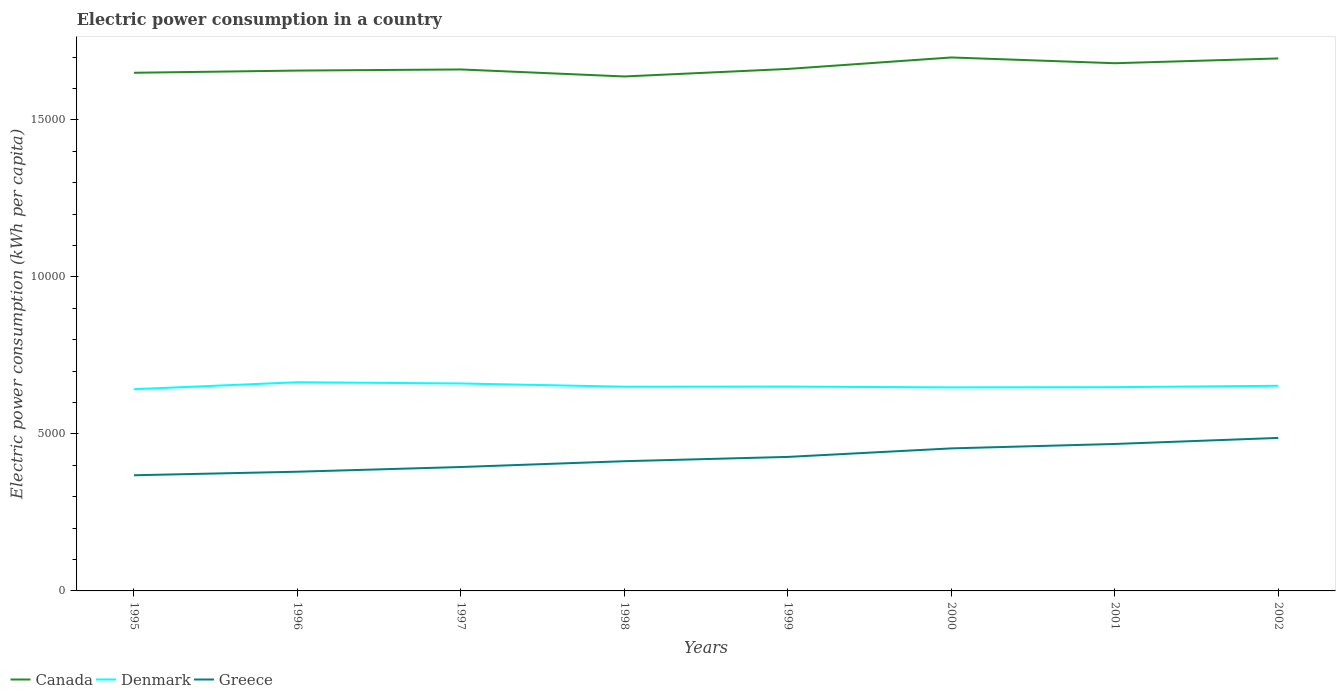How many different coloured lines are there?
Ensure brevity in your answer.  3. Does the line corresponding to Canada intersect with the line corresponding to Denmark?
Give a very brief answer. No. Across all years, what is the maximum electric power consumption in in Canada?
Ensure brevity in your answer.  1.64e+04. What is the total electric power consumption in in Canada in the graph?
Keep it short and to the point. -574.2. What is the difference between the highest and the second highest electric power consumption in in Greece?
Provide a succinct answer. 1189.32. What is the difference between the highest and the lowest electric power consumption in in Greece?
Ensure brevity in your answer.  4. How many lines are there?
Offer a very short reply. 3. How many years are there in the graph?
Your answer should be very brief. 8. Are the values on the major ticks of Y-axis written in scientific E-notation?
Offer a terse response. No. Where does the legend appear in the graph?
Offer a terse response. Bottom left. How many legend labels are there?
Your answer should be very brief. 3. How are the legend labels stacked?
Your response must be concise. Horizontal. What is the title of the graph?
Provide a succinct answer. Electric power consumption in a country. What is the label or title of the Y-axis?
Your answer should be very brief. Electric power consumption (kWh per capita). What is the Electric power consumption (kWh per capita) in Canada in 1995?
Ensure brevity in your answer.  1.65e+04. What is the Electric power consumption (kWh per capita) in Denmark in 1995?
Your response must be concise. 6424.54. What is the Electric power consumption (kWh per capita) in Greece in 1995?
Offer a terse response. 3683.8. What is the Electric power consumption (kWh per capita) in Canada in 1996?
Your answer should be compact. 1.66e+04. What is the Electric power consumption (kWh per capita) in Denmark in 1996?
Give a very brief answer. 6646.69. What is the Electric power consumption (kWh per capita) in Greece in 1996?
Offer a very short reply. 3796.75. What is the Electric power consumption (kWh per capita) of Canada in 1997?
Your response must be concise. 1.66e+04. What is the Electric power consumption (kWh per capita) of Denmark in 1997?
Your answer should be very brief. 6607.2. What is the Electric power consumption (kWh per capita) of Greece in 1997?
Offer a very short reply. 3946.46. What is the Electric power consumption (kWh per capita) in Canada in 1998?
Give a very brief answer. 1.64e+04. What is the Electric power consumption (kWh per capita) of Denmark in 1998?
Ensure brevity in your answer.  6504.26. What is the Electric power consumption (kWh per capita) in Greece in 1998?
Make the answer very short. 4131.66. What is the Electric power consumption (kWh per capita) in Canada in 1999?
Your answer should be very brief. 1.66e+04. What is the Electric power consumption (kWh per capita) in Denmark in 1999?
Your answer should be very brief. 6508.51. What is the Electric power consumption (kWh per capita) in Greece in 1999?
Your response must be concise. 4268.38. What is the Electric power consumption (kWh per capita) of Canada in 2000?
Provide a succinct answer. 1.70e+04. What is the Electric power consumption (kWh per capita) in Denmark in 2000?
Provide a short and direct response. 6482.49. What is the Electric power consumption (kWh per capita) in Greece in 2000?
Give a very brief answer. 4539.42. What is the Electric power consumption (kWh per capita) of Canada in 2001?
Provide a short and direct response. 1.68e+04. What is the Electric power consumption (kWh per capita) of Denmark in 2001?
Ensure brevity in your answer.  6490.09. What is the Electric power consumption (kWh per capita) in Greece in 2001?
Your answer should be very brief. 4680.52. What is the Electric power consumption (kWh per capita) in Canada in 2002?
Offer a terse response. 1.70e+04. What is the Electric power consumption (kWh per capita) in Denmark in 2002?
Your answer should be very brief. 6533.75. What is the Electric power consumption (kWh per capita) in Greece in 2002?
Your answer should be compact. 4873.12. Across all years, what is the maximum Electric power consumption (kWh per capita) in Canada?
Make the answer very short. 1.70e+04. Across all years, what is the maximum Electric power consumption (kWh per capita) of Denmark?
Make the answer very short. 6646.69. Across all years, what is the maximum Electric power consumption (kWh per capita) of Greece?
Ensure brevity in your answer.  4873.12. Across all years, what is the minimum Electric power consumption (kWh per capita) of Canada?
Give a very brief answer. 1.64e+04. Across all years, what is the minimum Electric power consumption (kWh per capita) of Denmark?
Your answer should be compact. 6424.54. Across all years, what is the minimum Electric power consumption (kWh per capita) of Greece?
Offer a terse response. 3683.8. What is the total Electric power consumption (kWh per capita) in Canada in the graph?
Keep it short and to the point. 1.33e+05. What is the total Electric power consumption (kWh per capita) of Denmark in the graph?
Give a very brief answer. 5.22e+04. What is the total Electric power consumption (kWh per capita) in Greece in the graph?
Your answer should be compact. 3.39e+04. What is the difference between the Electric power consumption (kWh per capita) in Canada in 1995 and that in 1996?
Offer a terse response. -69.41. What is the difference between the Electric power consumption (kWh per capita) in Denmark in 1995 and that in 1996?
Give a very brief answer. -222.15. What is the difference between the Electric power consumption (kWh per capita) of Greece in 1995 and that in 1996?
Provide a short and direct response. -112.94. What is the difference between the Electric power consumption (kWh per capita) in Canada in 1995 and that in 1997?
Offer a terse response. -105.28. What is the difference between the Electric power consumption (kWh per capita) in Denmark in 1995 and that in 1997?
Make the answer very short. -182.66. What is the difference between the Electric power consumption (kWh per capita) of Greece in 1995 and that in 1997?
Provide a succinct answer. -262.65. What is the difference between the Electric power consumption (kWh per capita) in Canada in 1995 and that in 1998?
Give a very brief answer. 117.87. What is the difference between the Electric power consumption (kWh per capita) of Denmark in 1995 and that in 1998?
Give a very brief answer. -79.72. What is the difference between the Electric power consumption (kWh per capita) of Greece in 1995 and that in 1998?
Your response must be concise. -447.85. What is the difference between the Electric power consumption (kWh per capita) in Canada in 1995 and that in 1999?
Offer a very short reply. -122.12. What is the difference between the Electric power consumption (kWh per capita) in Denmark in 1995 and that in 1999?
Your response must be concise. -83.98. What is the difference between the Electric power consumption (kWh per capita) in Greece in 1995 and that in 1999?
Your answer should be very brief. -584.58. What is the difference between the Electric power consumption (kWh per capita) of Canada in 1995 and that in 2000?
Provide a short and direct response. -487.31. What is the difference between the Electric power consumption (kWh per capita) in Denmark in 1995 and that in 2000?
Your answer should be very brief. -57.95. What is the difference between the Electric power consumption (kWh per capita) in Greece in 1995 and that in 2000?
Give a very brief answer. -855.61. What is the difference between the Electric power consumption (kWh per capita) of Canada in 1995 and that in 2001?
Make the answer very short. -303.87. What is the difference between the Electric power consumption (kWh per capita) of Denmark in 1995 and that in 2001?
Offer a very short reply. -65.56. What is the difference between the Electric power consumption (kWh per capita) of Greece in 1995 and that in 2001?
Offer a very short reply. -996.72. What is the difference between the Electric power consumption (kWh per capita) in Canada in 1995 and that in 2002?
Ensure brevity in your answer.  -456.33. What is the difference between the Electric power consumption (kWh per capita) in Denmark in 1995 and that in 2002?
Ensure brevity in your answer.  -109.21. What is the difference between the Electric power consumption (kWh per capita) in Greece in 1995 and that in 2002?
Provide a short and direct response. -1189.32. What is the difference between the Electric power consumption (kWh per capita) in Canada in 1996 and that in 1997?
Offer a very short reply. -35.87. What is the difference between the Electric power consumption (kWh per capita) in Denmark in 1996 and that in 1997?
Offer a terse response. 39.48. What is the difference between the Electric power consumption (kWh per capita) of Greece in 1996 and that in 1997?
Give a very brief answer. -149.71. What is the difference between the Electric power consumption (kWh per capita) in Canada in 1996 and that in 1998?
Your answer should be very brief. 187.28. What is the difference between the Electric power consumption (kWh per capita) of Denmark in 1996 and that in 1998?
Offer a very short reply. 142.43. What is the difference between the Electric power consumption (kWh per capita) of Greece in 1996 and that in 1998?
Provide a succinct answer. -334.91. What is the difference between the Electric power consumption (kWh per capita) in Canada in 1996 and that in 1999?
Your answer should be compact. -52.7. What is the difference between the Electric power consumption (kWh per capita) in Denmark in 1996 and that in 1999?
Offer a terse response. 138.17. What is the difference between the Electric power consumption (kWh per capita) of Greece in 1996 and that in 1999?
Offer a very short reply. -471.64. What is the difference between the Electric power consumption (kWh per capita) of Canada in 1996 and that in 2000?
Your response must be concise. -417.9. What is the difference between the Electric power consumption (kWh per capita) of Denmark in 1996 and that in 2000?
Give a very brief answer. 164.2. What is the difference between the Electric power consumption (kWh per capita) of Greece in 1996 and that in 2000?
Provide a succinct answer. -742.67. What is the difference between the Electric power consumption (kWh per capita) in Canada in 1996 and that in 2001?
Provide a succinct answer. -234.46. What is the difference between the Electric power consumption (kWh per capita) in Denmark in 1996 and that in 2001?
Make the answer very short. 156.59. What is the difference between the Electric power consumption (kWh per capita) in Greece in 1996 and that in 2001?
Offer a terse response. -883.78. What is the difference between the Electric power consumption (kWh per capita) of Canada in 1996 and that in 2002?
Give a very brief answer. -386.92. What is the difference between the Electric power consumption (kWh per capita) of Denmark in 1996 and that in 2002?
Offer a very short reply. 112.93. What is the difference between the Electric power consumption (kWh per capita) of Greece in 1996 and that in 2002?
Ensure brevity in your answer.  -1076.37. What is the difference between the Electric power consumption (kWh per capita) in Canada in 1997 and that in 1998?
Provide a succinct answer. 223.15. What is the difference between the Electric power consumption (kWh per capita) of Denmark in 1997 and that in 1998?
Provide a short and direct response. 102.95. What is the difference between the Electric power consumption (kWh per capita) in Greece in 1997 and that in 1998?
Ensure brevity in your answer.  -185.2. What is the difference between the Electric power consumption (kWh per capita) in Canada in 1997 and that in 1999?
Give a very brief answer. -16.83. What is the difference between the Electric power consumption (kWh per capita) of Denmark in 1997 and that in 1999?
Keep it short and to the point. 98.69. What is the difference between the Electric power consumption (kWh per capita) of Greece in 1997 and that in 1999?
Give a very brief answer. -321.93. What is the difference between the Electric power consumption (kWh per capita) in Canada in 1997 and that in 2000?
Keep it short and to the point. -382.03. What is the difference between the Electric power consumption (kWh per capita) in Denmark in 1997 and that in 2000?
Give a very brief answer. 124.71. What is the difference between the Electric power consumption (kWh per capita) of Greece in 1997 and that in 2000?
Keep it short and to the point. -592.96. What is the difference between the Electric power consumption (kWh per capita) of Canada in 1997 and that in 2001?
Your answer should be compact. -198.59. What is the difference between the Electric power consumption (kWh per capita) of Denmark in 1997 and that in 2001?
Ensure brevity in your answer.  117.11. What is the difference between the Electric power consumption (kWh per capita) of Greece in 1997 and that in 2001?
Offer a very short reply. -734.07. What is the difference between the Electric power consumption (kWh per capita) of Canada in 1997 and that in 2002?
Offer a very short reply. -351.05. What is the difference between the Electric power consumption (kWh per capita) in Denmark in 1997 and that in 2002?
Offer a terse response. 73.45. What is the difference between the Electric power consumption (kWh per capita) in Greece in 1997 and that in 2002?
Offer a terse response. -926.66. What is the difference between the Electric power consumption (kWh per capita) of Canada in 1998 and that in 1999?
Provide a short and direct response. -239.98. What is the difference between the Electric power consumption (kWh per capita) in Denmark in 1998 and that in 1999?
Your response must be concise. -4.26. What is the difference between the Electric power consumption (kWh per capita) of Greece in 1998 and that in 1999?
Your response must be concise. -136.72. What is the difference between the Electric power consumption (kWh per capita) of Canada in 1998 and that in 2000?
Ensure brevity in your answer.  -605.18. What is the difference between the Electric power consumption (kWh per capita) of Denmark in 1998 and that in 2000?
Provide a short and direct response. 21.77. What is the difference between the Electric power consumption (kWh per capita) of Greece in 1998 and that in 2000?
Provide a succinct answer. -407.76. What is the difference between the Electric power consumption (kWh per capita) of Canada in 1998 and that in 2001?
Ensure brevity in your answer.  -421.74. What is the difference between the Electric power consumption (kWh per capita) of Denmark in 1998 and that in 2001?
Give a very brief answer. 14.16. What is the difference between the Electric power consumption (kWh per capita) of Greece in 1998 and that in 2001?
Provide a short and direct response. -548.87. What is the difference between the Electric power consumption (kWh per capita) in Canada in 1998 and that in 2002?
Provide a succinct answer. -574.2. What is the difference between the Electric power consumption (kWh per capita) of Denmark in 1998 and that in 2002?
Your answer should be very brief. -29.5. What is the difference between the Electric power consumption (kWh per capita) in Greece in 1998 and that in 2002?
Offer a terse response. -741.46. What is the difference between the Electric power consumption (kWh per capita) in Canada in 1999 and that in 2000?
Keep it short and to the point. -365.19. What is the difference between the Electric power consumption (kWh per capita) in Denmark in 1999 and that in 2000?
Your answer should be very brief. 26.02. What is the difference between the Electric power consumption (kWh per capita) of Greece in 1999 and that in 2000?
Your response must be concise. -271.04. What is the difference between the Electric power consumption (kWh per capita) in Canada in 1999 and that in 2001?
Your answer should be compact. -181.76. What is the difference between the Electric power consumption (kWh per capita) of Denmark in 1999 and that in 2001?
Your answer should be very brief. 18.42. What is the difference between the Electric power consumption (kWh per capita) of Greece in 1999 and that in 2001?
Keep it short and to the point. -412.14. What is the difference between the Electric power consumption (kWh per capita) in Canada in 1999 and that in 2002?
Your answer should be compact. -334.21. What is the difference between the Electric power consumption (kWh per capita) of Denmark in 1999 and that in 2002?
Offer a very short reply. -25.24. What is the difference between the Electric power consumption (kWh per capita) of Greece in 1999 and that in 2002?
Keep it short and to the point. -604.74. What is the difference between the Electric power consumption (kWh per capita) of Canada in 2000 and that in 2001?
Offer a terse response. 183.43. What is the difference between the Electric power consumption (kWh per capita) of Denmark in 2000 and that in 2001?
Give a very brief answer. -7.6. What is the difference between the Electric power consumption (kWh per capita) in Greece in 2000 and that in 2001?
Provide a short and direct response. -141.11. What is the difference between the Electric power consumption (kWh per capita) of Canada in 2000 and that in 2002?
Your answer should be compact. 30.98. What is the difference between the Electric power consumption (kWh per capita) of Denmark in 2000 and that in 2002?
Ensure brevity in your answer.  -51.26. What is the difference between the Electric power consumption (kWh per capita) of Greece in 2000 and that in 2002?
Your response must be concise. -333.7. What is the difference between the Electric power consumption (kWh per capita) of Canada in 2001 and that in 2002?
Give a very brief answer. -152.46. What is the difference between the Electric power consumption (kWh per capita) of Denmark in 2001 and that in 2002?
Provide a succinct answer. -43.66. What is the difference between the Electric power consumption (kWh per capita) of Greece in 2001 and that in 2002?
Provide a succinct answer. -192.6. What is the difference between the Electric power consumption (kWh per capita) of Canada in 1995 and the Electric power consumption (kWh per capita) of Denmark in 1996?
Offer a very short reply. 9856.58. What is the difference between the Electric power consumption (kWh per capita) in Canada in 1995 and the Electric power consumption (kWh per capita) in Greece in 1996?
Give a very brief answer. 1.27e+04. What is the difference between the Electric power consumption (kWh per capita) in Denmark in 1995 and the Electric power consumption (kWh per capita) in Greece in 1996?
Provide a succinct answer. 2627.79. What is the difference between the Electric power consumption (kWh per capita) of Canada in 1995 and the Electric power consumption (kWh per capita) of Denmark in 1997?
Ensure brevity in your answer.  9896.07. What is the difference between the Electric power consumption (kWh per capita) of Canada in 1995 and the Electric power consumption (kWh per capita) of Greece in 1997?
Provide a succinct answer. 1.26e+04. What is the difference between the Electric power consumption (kWh per capita) in Denmark in 1995 and the Electric power consumption (kWh per capita) in Greece in 1997?
Your response must be concise. 2478.08. What is the difference between the Electric power consumption (kWh per capita) in Canada in 1995 and the Electric power consumption (kWh per capita) in Denmark in 1998?
Make the answer very short. 9999.01. What is the difference between the Electric power consumption (kWh per capita) of Canada in 1995 and the Electric power consumption (kWh per capita) of Greece in 1998?
Offer a terse response. 1.24e+04. What is the difference between the Electric power consumption (kWh per capita) in Denmark in 1995 and the Electric power consumption (kWh per capita) in Greece in 1998?
Provide a succinct answer. 2292.88. What is the difference between the Electric power consumption (kWh per capita) in Canada in 1995 and the Electric power consumption (kWh per capita) in Denmark in 1999?
Your answer should be compact. 9994.76. What is the difference between the Electric power consumption (kWh per capita) of Canada in 1995 and the Electric power consumption (kWh per capita) of Greece in 1999?
Provide a succinct answer. 1.22e+04. What is the difference between the Electric power consumption (kWh per capita) of Denmark in 1995 and the Electric power consumption (kWh per capita) of Greece in 1999?
Keep it short and to the point. 2156.16. What is the difference between the Electric power consumption (kWh per capita) in Canada in 1995 and the Electric power consumption (kWh per capita) in Denmark in 2000?
Keep it short and to the point. 1.00e+04. What is the difference between the Electric power consumption (kWh per capita) in Canada in 1995 and the Electric power consumption (kWh per capita) in Greece in 2000?
Provide a succinct answer. 1.20e+04. What is the difference between the Electric power consumption (kWh per capita) in Denmark in 1995 and the Electric power consumption (kWh per capita) in Greece in 2000?
Keep it short and to the point. 1885.12. What is the difference between the Electric power consumption (kWh per capita) of Canada in 1995 and the Electric power consumption (kWh per capita) of Denmark in 2001?
Keep it short and to the point. 1.00e+04. What is the difference between the Electric power consumption (kWh per capita) of Canada in 1995 and the Electric power consumption (kWh per capita) of Greece in 2001?
Give a very brief answer. 1.18e+04. What is the difference between the Electric power consumption (kWh per capita) of Denmark in 1995 and the Electric power consumption (kWh per capita) of Greece in 2001?
Keep it short and to the point. 1744.01. What is the difference between the Electric power consumption (kWh per capita) in Canada in 1995 and the Electric power consumption (kWh per capita) in Denmark in 2002?
Provide a succinct answer. 9969.52. What is the difference between the Electric power consumption (kWh per capita) of Canada in 1995 and the Electric power consumption (kWh per capita) of Greece in 2002?
Offer a very short reply. 1.16e+04. What is the difference between the Electric power consumption (kWh per capita) in Denmark in 1995 and the Electric power consumption (kWh per capita) in Greece in 2002?
Provide a succinct answer. 1551.42. What is the difference between the Electric power consumption (kWh per capita) of Canada in 1996 and the Electric power consumption (kWh per capita) of Denmark in 1997?
Keep it short and to the point. 9965.48. What is the difference between the Electric power consumption (kWh per capita) in Canada in 1996 and the Electric power consumption (kWh per capita) in Greece in 1997?
Provide a succinct answer. 1.26e+04. What is the difference between the Electric power consumption (kWh per capita) in Denmark in 1996 and the Electric power consumption (kWh per capita) in Greece in 1997?
Provide a short and direct response. 2700.23. What is the difference between the Electric power consumption (kWh per capita) of Canada in 1996 and the Electric power consumption (kWh per capita) of Denmark in 1998?
Make the answer very short. 1.01e+04. What is the difference between the Electric power consumption (kWh per capita) in Canada in 1996 and the Electric power consumption (kWh per capita) in Greece in 1998?
Your response must be concise. 1.24e+04. What is the difference between the Electric power consumption (kWh per capita) in Denmark in 1996 and the Electric power consumption (kWh per capita) in Greece in 1998?
Ensure brevity in your answer.  2515.03. What is the difference between the Electric power consumption (kWh per capita) in Canada in 1996 and the Electric power consumption (kWh per capita) in Denmark in 1999?
Your response must be concise. 1.01e+04. What is the difference between the Electric power consumption (kWh per capita) in Canada in 1996 and the Electric power consumption (kWh per capita) in Greece in 1999?
Offer a terse response. 1.23e+04. What is the difference between the Electric power consumption (kWh per capita) in Denmark in 1996 and the Electric power consumption (kWh per capita) in Greece in 1999?
Offer a very short reply. 2378.3. What is the difference between the Electric power consumption (kWh per capita) in Canada in 1996 and the Electric power consumption (kWh per capita) in Denmark in 2000?
Ensure brevity in your answer.  1.01e+04. What is the difference between the Electric power consumption (kWh per capita) in Canada in 1996 and the Electric power consumption (kWh per capita) in Greece in 2000?
Offer a very short reply. 1.20e+04. What is the difference between the Electric power consumption (kWh per capita) of Denmark in 1996 and the Electric power consumption (kWh per capita) of Greece in 2000?
Keep it short and to the point. 2107.27. What is the difference between the Electric power consumption (kWh per capita) in Canada in 1996 and the Electric power consumption (kWh per capita) in Denmark in 2001?
Provide a succinct answer. 1.01e+04. What is the difference between the Electric power consumption (kWh per capita) of Canada in 1996 and the Electric power consumption (kWh per capita) of Greece in 2001?
Provide a succinct answer. 1.19e+04. What is the difference between the Electric power consumption (kWh per capita) of Denmark in 1996 and the Electric power consumption (kWh per capita) of Greece in 2001?
Provide a succinct answer. 1966.16. What is the difference between the Electric power consumption (kWh per capita) of Canada in 1996 and the Electric power consumption (kWh per capita) of Denmark in 2002?
Provide a short and direct response. 1.00e+04. What is the difference between the Electric power consumption (kWh per capita) of Canada in 1996 and the Electric power consumption (kWh per capita) of Greece in 2002?
Provide a short and direct response. 1.17e+04. What is the difference between the Electric power consumption (kWh per capita) of Denmark in 1996 and the Electric power consumption (kWh per capita) of Greece in 2002?
Ensure brevity in your answer.  1773.57. What is the difference between the Electric power consumption (kWh per capita) of Canada in 1997 and the Electric power consumption (kWh per capita) of Denmark in 1998?
Give a very brief answer. 1.01e+04. What is the difference between the Electric power consumption (kWh per capita) of Canada in 1997 and the Electric power consumption (kWh per capita) of Greece in 1998?
Keep it short and to the point. 1.25e+04. What is the difference between the Electric power consumption (kWh per capita) in Denmark in 1997 and the Electric power consumption (kWh per capita) in Greece in 1998?
Keep it short and to the point. 2475.55. What is the difference between the Electric power consumption (kWh per capita) in Canada in 1997 and the Electric power consumption (kWh per capita) in Denmark in 1999?
Your response must be concise. 1.01e+04. What is the difference between the Electric power consumption (kWh per capita) of Canada in 1997 and the Electric power consumption (kWh per capita) of Greece in 1999?
Provide a succinct answer. 1.23e+04. What is the difference between the Electric power consumption (kWh per capita) of Denmark in 1997 and the Electric power consumption (kWh per capita) of Greece in 1999?
Offer a very short reply. 2338.82. What is the difference between the Electric power consumption (kWh per capita) in Canada in 1997 and the Electric power consumption (kWh per capita) in Denmark in 2000?
Provide a succinct answer. 1.01e+04. What is the difference between the Electric power consumption (kWh per capita) of Canada in 1997 and the Electric power consumption (kWh per capita) of Greece in 2000?
Provide a short and direct response. 1.21e+04. What is the difference between the Electric power consumption (kWh per capita) in Denmark in 1997 and the Electric power consumption (kWh per capita) in Greece in 2000?
Provide a succinct answer. 2067.78. What is the difference between the Electric power consumption (kWh per capita) in Canada in 1997 and the Electric power consumption (kWh per capita) in Denmark in 2001?
Your answer should be very brief. 1.01e+04. What is the difference between the Electric power consumption (kWh per capita) in Canada in 1997 and the Electric power consumption (kWh per capita) in Greece in 2001?
Your answer should be compact. 1.19e+04. What is the difference between the Electric power consumption (kWh per capita) of Denmark in 1997 and the Electric power consumption (kWh per capita) of Greece in 2001?
Your answer should be compact. 1926.68. What is the difference between the Electric power consumption (kWh per capita) of Canada in 1997 and the Electric power consumption (kWh per capita) of Denmark in 2002?
Give a very brief answer. 1.01e+04. What is the difference between the Electric power consumption (kWh per capita) in Canada in 1997 and the Electric power consumption (kWh per capita) in Greece in 2002?
Ensure brevity in your answer.  1.17e+04. What is the difference between the Electric power consumption (kWh per capita) of Denmark in 1997 and the Electric power consumption (kWh per capita) of Greece in 2002?
Give a very brief answer. 1734.08. What is the difference between the Electric power consumption (kWh per capita) in Canada in 1998 and the Electric power consumption (kWh per capita) in Denmark in 1999?
Give a very brief answer. 9876.89. What is the difference between the Electric power consumption (kWh per capita) of Canada in 1998 and the Electric power consumption (kWh per capita) of Greece in 1999?
Offer a very short reply. 1.21e+04. What is the difference between the Electric power consumption (kWh per capita) of Denmark in 1998 and the Electric power consumption (kWh per capita) of Greece in 1999?
Keep it short and to the point. 2235.88. What is the difference between the Electric power consumption (kWh per capita) of Canada in 1998 and the Electric power consumption (kWh per capita) of Denmark in 2000?
Offer a terse response. 9902.91. What is the difference between the Electric power consumption (kWh per capita) in Canada in 1998 and the Electric power consumption (kWh per capita) in Greece in 2000?
Your response must be concise. 1.18e+04. What is the difference between the Electric power consumption (kWh per capita) in Denmark in 1998 and the Electric power consumption (kWh per capita) in Greece in 2000?
Give a very brief answer. 1964.84. What is the difference between the Electric power consumption (kWh per capita) of Canada in 1998 and the Electric power consumption (kWh per capita) of Denmark in 2001?
Your answer should be compact. 9895.31. What is the difference between the Electric power consumption (kWh per capita) in Canada in 1998 and the Electric power consumption (kWh per capita) in Greece in 2001?
Provide a succinct answer. 1.17e+04. What is the difference between the Electric power consumption (kWh per capita) of Denmark in 1998 and the Electric power consumption (kWh per capita) of Greece in 2001?
Make the answer very short. 1823.73. What is the difference between the Electric power consumption (kWh per capita) of Canada in 1998 and the Electric power consumption (kWh per capita) of Denmark in 2002?
Your answer should be compact. 9851.65. What is the difference between the Electric power consumption (kWh per capita) in Canada in 1998 and the Electric power consumption (kWh per capita) in Greece in 2002?
Offer a very short reply. 1.15e+04. What is the difference between the Electric power consumption (kWh per capita) in Denmark in 1998 and the Electric power consumption (kWh per capita) in Greece in 2002?
Ensure brevity in your answer.  1631.14. What is the difference between the Electric power consumption (kWh per capita) in Canada in 1999 and the Electric power consumption (kWh per capita) in Denmark in 2000?
Ensure brevity in your answer.  1.01e+04. What is the difference between the Electric power consumption (kWh per capita) in Canada in 1999 and the Electric power consumption (kWh per capita) in Greece in 2000?
Offer a very short reply. 1.21e+04. What is the difference between the Electric power consumption (kWh per capita) of Denmark in 1999 and the Electric power consumption (kWh per capita) of Greece in 2000?
Provide a short and direct response. 1969.1. What is the difference between the Electric power consumption (kWh per capita) in Canada in 1999 and the Electric power consumption (kWh per capita) in Denmark in 2001?
Your answer should be very brief. 1.01e+04. What is the difference between the Electric power consumption (kWh per capita) in Canada in 1999 and the Electric power consumption (kWh per capita) in Greece in 2001?
Provide a succinct answer. 1.19e+04. What is the difference between the Electric power consumption (kWh per capita) of Denmark in 1999 and the Electric power consumption (kWh per capita) of Greece in 2001?
Provide a succinct answer. 1827.99. What is the difference between the Electric power consumption (kWh per capita) of Canada in 1999 and the Electric power consumption (kWh per capita) of Denmark in 2002?
Make the answer very short. 1.01e+04. What is the difference between the Electric power consumption (kWh per capita) of Canada in 1999 and the Electric power consumption (kWh per capita) of Greece in 2002?
Provide a succinct answer. 1.18e+04. What is the difference between the Electric power consumption (kWh per capita) in Denmark in 1999 and the Electric power consumption (kWh per capita) in Greece in 2002?
Provide a short and direct response. 1635.39. What is the difference between the Electric power consumption (kWh per capita) in Canada in 2000 and the Electric power consumption (kWh per capita) in Denmark in 2001?
Provide a short and direct response. 1.05e+04. What is the difference between the Electric power consumption (kWh per capita) in Canada in 2000 and the Electric power consumption (kWh per capita) in Greece in 2001?
Provide a short and direct response. 1.23e+04. What is the difference between the Electric power consumption (kWh per capita) in Denmark in 2000 and the Electric power consumption (kWh per capita) in Greece in 2001?
Offer a very short reply. 1801.96. What is the difference between the Electric power consumption (kWh per capita) of Canada in 2000 and the Electric power consumption (kWh per capita) of Denmark in 2002?
Your answer should be very brief. 1.05e+04. What is the difference between the Electric power consumption (kWh per capita) in Canada in 2000 and the Electric power consumption (kWh per capita) in Greece in 2002?
Your response must be concise. 1.21e+04. What is the difference between the Electric power consumption (kWh per capita) in Denmark in 2000 and the Electric power consumption (kWh per capita) in Greece in 2002?
Offer a terse response. 1609.37. What is the difference between the Electric power consumption (kWh per capita) in Canada in 2001 and the Electric power consumption (kWh per capita) in Denmark in 2002?
Your answer should be compact. 1.03e+04. What is the difference between the Electric power consumption (kWh per capita) in Canada in 2001 and the Electric power consumption (kWh per capita) in Greece in 2002?
Your response must be concise. 1.19e+04. What is the difference between the Electric power consumption (kWh per capita) in Denmark in 2001 and the Electric power consumption (kWh per capita) in Greece in 2002?
Make the answer very short. 1616.97. What is the average Electric power consumption (kWh per capita) of Canada per year?
Ensure brevity in your answer.  1.67e+04. What is the average Electric power consumption (kWh per capita) in Denmark per year?
Make the answer very short. 6524.69. What is the average Electric power consumption (kWh per capita) in Greece per year?
Your response must be concise. 4240.01. In the year 1995, what is the difference between the Electric power consumption (kWh per capita) in Canada and Electric power consumption (kWh per capita) in Denmark?
Give a very brief answer. 1.01e+04. In the year 1995, what is the difference between the Electric power consumption (kWh per capita) of Canada and Electric power consumption (kWh per capita) of Greece?
Provide a short and direct response. 1.28e+04. In the year 1995, what is the difference between the Electric power consumption (kWh per capita) of Denmark and Electric power consumption (kWh per capita) of Greece?
Offer a terse response. 2740.73. In the year 1996, what is the difference between the Electric power consumption (kWh per capita) in Canada and Electric power consumption (kWh per capita) in Denmark?
Provide a succinct answer. 9926. In the year 1996, what is the difference between the Electric power consumption (kWh per capita) in Canada and Electric power consumption (kWh per capita) in Greece?
Your answer should be very brief. 1.28e+04. In the year 1996, what is the difference between the Electric power consumption (kWh per capita) in Denmark and Electric power consumption (kWh per capita) in Greece?
Provide a succinct answer. 2849.94. In the year 1997, what is the difference between the Electric power consumption (kWh per capita) of Canada and Electric power consumption (kWh per capita) of Denmark?
Offer a very short reply. 1.00e+04. In the year 1997, what is the difference between the Electric power consumption (kWh per capita) of Canada and Electric power consumption (kWh per capita) of Greece?
Provide a succinct answer. 1.27e+04. In the year 1997, what is the difference between the Electric power consumption (kWh per capita) in Denmark and Electric power consumption (kWh per capita) in Greece?
Offer a very short reply. 2660.75. In the year 1998, what is the difference between the Electric power consumption (kWh per capita) in Canada and Electric power consumption (kWh per capita) in Denmark?
Your answer should be very brief. 9881.15. In the year 1998, what is the difference between the Electric power consumption (kWh per capita) in Canada and Electric power consumption (kWh per capita) in Greece?
Your answer should be compact. 1.23e+04. In the year 1998, what is the difference between the Electric power consumption (kWh per capita) of Denmark and Electric power consumption (kWh per capita) of Greece?
Your response must be concise. 2372.6. In the year 1999, what is the difference between the Electric power consumption (kWh per capita) in Canada and Electric power consumption (kWh per capita) in Denmark?
Your response must be concise. 1.01e+04. In the year 1999, what is the difference between the Electric power consumption (kWh per capita) of Canada and Electric power consumption (kWh per capita) of Greece?
Provide a succinct answer. 1.24e+04. In the year 1999, what is the difference between the Electric power consumption (kWh per capita) of Denmark and Electric power consumption (kWh per capita) of Greece?
Ensure brevity in your answer.  2240.13. In the year 2000, what is the difference between the Electric power consumption (kWh per capita) in Canada and Electric power consumption (kWh per capita) in Denmark?
Your answer should be compact. 1.05e+04. In the year 2000, what is the difference between the Electric power consumption (kWh per capita) in Canada and Electric power consumption (kWh per capita) in Greece?
Keep it short and to the point. 1.25e+04. In the year 2000, what is the difference between the Electric power consumption (kWh per capita) in Denmark and Electric power consumption (kWh per capita) in Greece?
Make the answer very short. 1943.07. In the year 2001, what is the difference between the Electric power consumption (kWh per capita) of Canada and Electric power consumption (kWh per capita) of Denmark?
Make the answer very short. 1.03e+04. In the year 2001, what is the difference between the Electric power consumption (kWh per capita) of Canada and Electric power consumption (kWh per capita) of Greece?
Ensure brevity in your answer.  1.21e+04. In the year 2001, what is the difference between the Electric power consumption (kWh per capita) of Denmark and Electric power consumption (kWh per capita) of Greece?
Keep it short and to the point. 1809.57. In the year 2002, what is the difference between the Electric power consumption (kWh per capita) of Canada and Electric power consumption (kWh per capita) of Denmark?
Make the answer very short. 1.04e+04. In the year 2002, what is the difference between the Electric power consumption (kWh per capita) of Canada and Electric power consumption (kWh per capita) of Greece?
Keep it short and to the point. 1.21e+04. In the year 2002, what is the difference between the Electric power consumption (kWh per capita) of Denmark and Electric power consumption (kWh per capita) of Greece?
Offer a very short reply. 1660.63. What is the ratio of the Electric power consumption (kWh per capita) of Canada in 1995 to that in 1996?
Provide a short and direct response. 1. What is the ratio of the Electric power consumption (kWh per capita) of Denmark in 1995 to that in 1996?
Provide a short and direct response. 0.97. What is the ratio of the Electric power consumption (kWh per capita) of Greece in 1995 to that in 1996?
Keep it short and to the point. 0.97. What is the ratio of the Electric power consumption (kWh per capita) of Denmark in 1995 to that in 1997?
Offer a very short reply. 0.97. What is the ratio of the Electric power consumption (kWh per capita) in Greece in 1995 to that in 1997?
Keep it short and to the point. 0.93. What is the ratio of the Electric power consumption (kWh per capita) in Denmark in 1995 to that in 1998?
Make the answer very short. 0.99. What is the ratio of the Electric power consumption (kWh per capita) of Greece in 1995 to that in 1998?
Give a very brief answer. 0.89. What is the ratio of the Electric power consumption (kWh per capita) in Canada in 1995 to that in 1999?
Provide a short and direct response. 0.99. What is the ratio of the Electric power consumption (kWh per capita) in Denmark in 1995 to that in 1999?
Keep it short and to the point. 0.99. What is the ratio of the Electric power consumption (kWh per capita) of Greece in 1995 to that in 1999?
Your answer should be compact. 0.86. What is the ratio of the Electric power consumption (kWh per capita) of Canada in 1995 to that in 2000?
Your response must be concise. 0.97. What is the ratio of the Electric power consumption (kWh per capita) in Denmark in 1995 to that in 2000?
Your answer should be very brief. 0.99. What is the ratio of the Electric power consumption (kWh per capita) in Greece in 1995 to that in 2000?
Offer a terse response. 0.81. What is the ratio of the Electric power consumption (kWh per capita) of Canada in 1995 to that in 2001?
Your answer should be compact. 0.98. What is the ratio of the Electric power consumption (kWh per capita) of Denmark in 1995 to that in 2001?
Keep it short and to the point. 0.99. What is the ratio of the Electric power consumption (kWh per capita) of Greece in 1995 to that in 2001?
Make the answer very short. 0.79. What is the ratio of the Electric power consumption (kWh per capita) in Canada in 1995 to that in 2002?
Your response must be concise. 0.97. What is the ratio of the Electric power consumption (kWh per capita) of Denmark in 1995 to that in 2002?
Provide a succinct answer. 0.98. What is the ratio of the Electric power consumption (kWh per capita) in Greece in 1995 to that in 2002?
Your response must be concise. 0.76. What is the ratio of the Electric power consumption (kWh per capita) in Greece in 1996 to that in 1997?
Your response must be concise. 0.96. What is the ratio of the Electric power consumption (kWh per capita) in Canada in 1996 to that in 1998?
Your answer should be very brief. 1.01. What is the ratio of the Electric power consumption (kWh per capita) of Denmark in 1996 to that in 1998?
Make the answer very short. 1.02. What is the ratio of the Electric power consumption (kWh per capita) in Greece in 1996 to that in 1998?
Offer a very short reply. 0.92. What is the ratio of the Electric power consumption (kWh per capita) in Canada in 1996 to that in 1999?
Your answer should be very brief. 1. What is the ratio of the Electric power consumption (kWh per capita) of Denmark in 1996 to that in 1999?
Keep it short and to the point. 1.02. What is the ratio of the Electric power consumption (kWh per capita) of Greece in 1996 to that in 1999?
Offer a terse response. 0.89. What is the ratio of the Electric power consumption (kWh per capita) in Canada in 1996 to that in 2000?
Your answer should be very brief. 0.98. What is the ratio of the Electric power consumption (kWh per capita) in Denmark in 1996 to that in 2000?
Offer a terse response. 1.03. What is the ratio of the Electric power consumption (kWh per capita) of Greece in 1996 to that in 2000?
Offer a terse response. 0.84. What is the ratio of the Electric power consumption (kWh per capita) of Denmark in 1996 to that in 2001?
Your response must be concise. 1.02. What is the ratio of the Electric power consumption (kWh per capita) of Greece in 1996 to that in 2001?
Your answer should be very brief. 0.81. What is the ratio of the Electric power consumption (kWh per capita) in Canada in 1996 to that in 2002?
Make the answer very short. 0.98. What is the ratio of the Electric power consumption (kWh per capita) of Denmark in 1996 to that in 2002?
Your answer should be very brief. 1.02. What is the ratio of the Electric power consumption (kWh per capita) of Greece in 1996 to that in 2002?
Offer a terse response. 0.78. What is the ratio of the Electric power consumption (kWh per capita) in Canada in 1997 to that in 1998?
Offer a terse response. 1.01. What is the ratio of the Electric power consumption (kWh per capita) in Denmark in 1997 to that in 1998?
Give a very brief answer. 1.02. What is the ratio of the Electric power consumption (kWh per capita) of Greece in 1997 to that in 1998?
Your answer should be compact. 0.96. What is the ratio of the Electric power consumption (kWh per capita) of Denmark in 1997 to that in 1999?
Your response must be concise. 1.02. What is the ratio of the Electric power consumption (kWh per capita) of Greece in 1997 to that in 1999?
Offer a very short reply. 0.92. What is the ratio of the Electric power consumption (kWh per capita) in Canada in 1997 to that in 2000?
Your answer should be compact. 0.98. What is the ratio of the Electric power consumption (kWh per capita) in Denmark in 1997 to that in 2000?
Your answer should be compact. 1.02. What is the ratio of the Electric power consumption (kWh per capita) of Greece in 1997 to that in 2000?
Make the answer very short. 0.87. What is the ratio of the Electric power consumption (kWh per capita) of Canada in 1997 to that in 2001?
Offer a terse response. 0.99. What is the ratio of the Electric power consumption (kWh per capita) in Greece in 1997 to that in 2001?
Provide a succinct answer. 0.84. What is the ratio of the Electric power consumption (kWh per capita) in Canada in 1997 to that in 2002?
Ensure brevity in your answer.  0.98. What is the ratio of the Electric power consumption (kWh per capita) of Denmark in 1997 to that in 2002?
Make the answer very short. 1.01. What is the ratio of the Electric power consumption (kWh per capita) of Greece in 1997 to that in 2002?
Your answer should be very brief. 0.81. What is the ratio of the Electric power consumption (kWh per capita) in Canada in 1998 to that in 1999?
Provide a short and direct response. 0.99. What is the ratio of the Electric power consumption (kWh per capita) of Greece in 1998 to that in 1999?
Your answer should be compact. 0.97. What is the ratio of the Electric power consumption (kWh per capita) of Canada in 1998 to that in 2000?
Offer a very short reply. 0.96. What is the ratio of the Electric power consumption (kWh per capita) in Greece in 1998 to that in 2000?
Provide a succinct answer. 0.91. What is the ratio of the Electric power consumption (kWh per capita) in Canada in 1998 to that in 2001?
Make the answer very short. 0.97. What is the ratio of the Electric power consumption (kWh per capita) in Greece in 1998 to that in 2001?
Your response must be concise. 0.88. What is the ratio of the Electric power consumption (kWh per capita) of Canada in 1998 to that in 2002?
Keep it short and to the point. 0.97. What is the ratio of the Electric power consumption (kWh per capita) of Denmark in 1998 to that in 2002?
Give a very brief answer. 1. What is the ratio of the Electric power consumption (kWh per capita) of Greece in 1998 to that in 2002?
Make the answer very short. 0.85. What is the ratio of the Electric power consumption (kWh per capita) of Canada in 1999 to that in 2000?
Give a very brief answer. 0.98. What is the ratio of the Electric power consumption (kWh per capita) of Greece in 1999 to that in 2000?
Keep it short and to the point. 0.94. What is the ratio of the Electric power consumption (kWh per capita) in Greece in 1999 to that in 2001?
Your answer should be compact. 0.91. What is the ratio of the Electric power consumption (kWh per capita) in Canada in 1999 to that in 2002?
Offer a terse response. 0.98. What is the ratio of the Electric power consumption (kWh per capita) of Denmark in 1999 to that in 2002?
Offer a very short reply. 1. What is the ratio of the Electric power consumption (kWh per capita) in Greece in 1999 to that in 2002?
Give a very brief answer. 0.88. What is the ratio of the Electric power consumption (kWh per capita) of Canada in 2000 to that in 2001?
Offer a very short reply. 1.01. What is the ratio of the Electric power consumption (kWh per capita) in Denmark in 2000 to that in 2001?
Your response must be concise. 1. What is the ratio of the Electric power consumption (kWh per capita) in Greece in 2000 to that in 2001?
Keep it short and to the point. 0.97. What is the ratio of the Electric power consumption (kWh per capita) in Canada in 2000 to that in 2002?
Give a very brief answer. 1. What is the ratio of the Electric power consumption (kWh per capita) of Denmark in 2000 to that in 2002?
Ensure brevity in your answer.  0.99. What is the ratio of the Electric power consumption (kWh per capita) of Greece in 2000 to that in 2002?
Make the answer very short. 0.93. What is the ratio of the Electric power consumption (kWh per capita) in Greece in 2001 to that in 2002?
Ensure brevity in your answer.  0.96. What is the difference between the highest and the second highest Electric power consumption (kWh per capita) in Canada?
Your answer should be very brief. 30.98. What is the difference between the highest and the second highest Electric power consumption (kWh per capita) in Denmark?
Provide a succinct answer. 39.48. What is the difference between the highest and the second highest Electric power consumption (kWh per capita) in Greece?
Offer a very short reply. 192.6. What is the difference between the highest and the lowest Electric power consumption (kWh per capita) in Canada?
Ensure brevity in your answer.  605.18. What is the difference between the highest and the lowest Electric power consumption (kWh per capita) in Denmark?
Provide a short and direct response. 222.15. What is the difference between the highest and the lowest Electric power consumption (kWh per capita) in Greece?
Keep it short and to the point. 1189.32. 